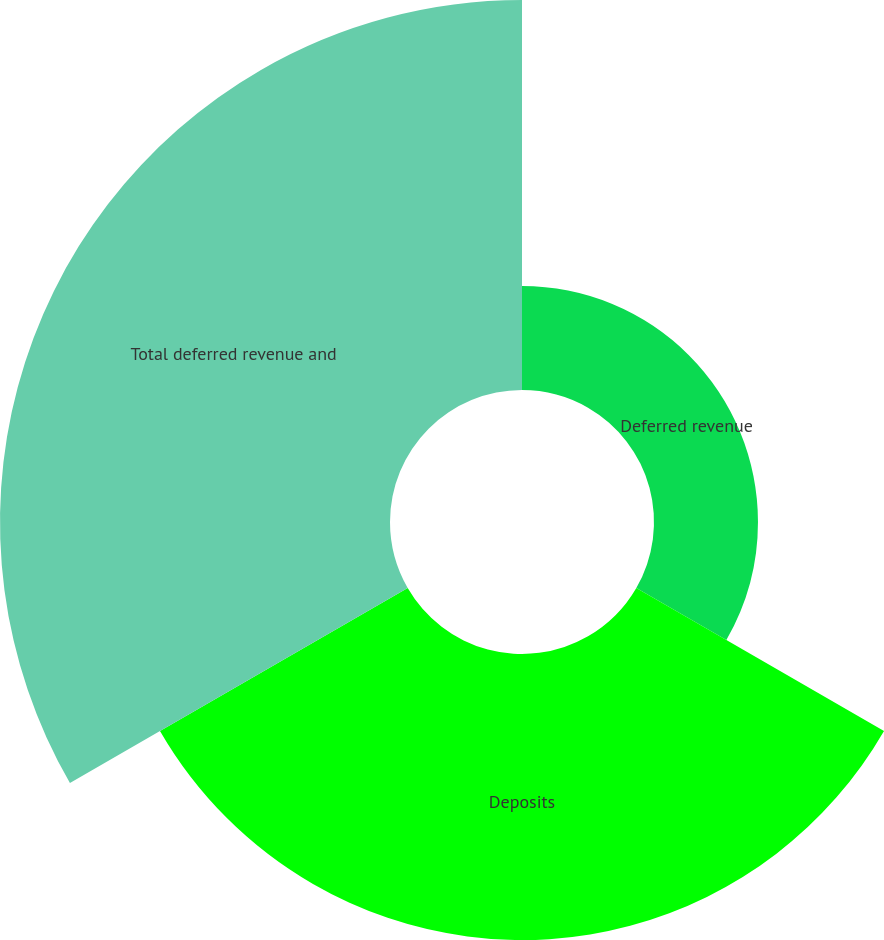Convert chart to OTSL. <chart><loc_0><loc_0><loc_500><loc_500><pie_chart><fcel>Deferred revenue<fcel>Deposits<fcel>Total deferred revenue and<nl><fcel>13.33%<fcel>36.67%<fcel>50.0%<nl></chart> 